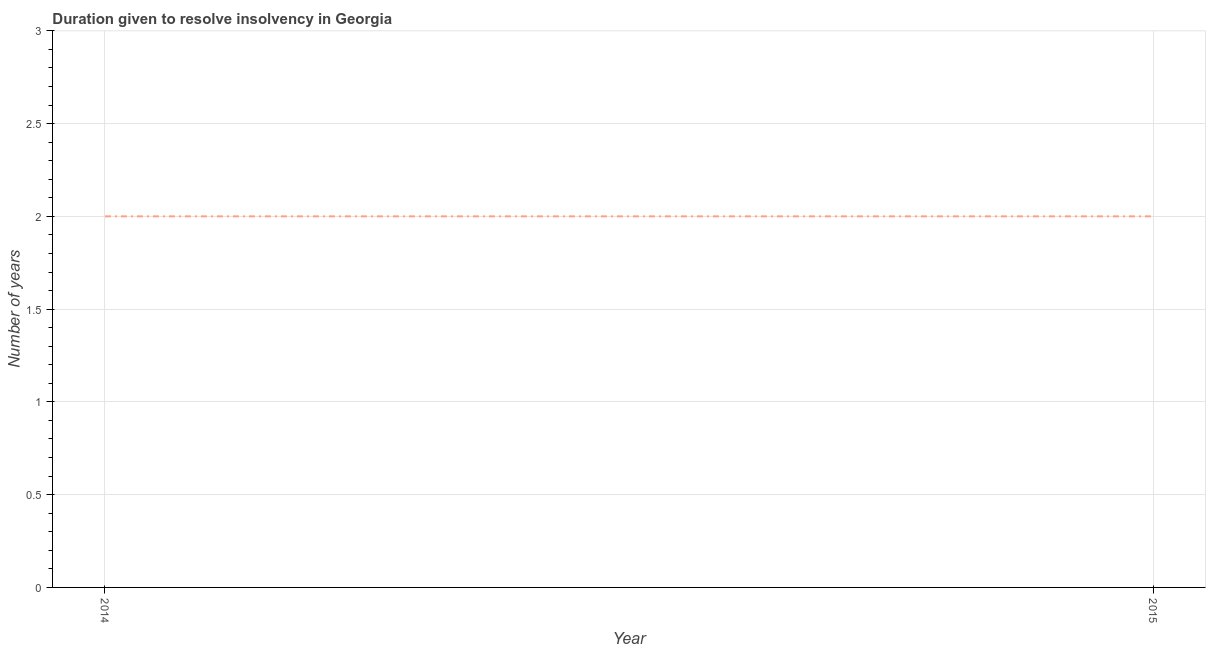What is the number of years to resolve insolvency in 2015?
Provide a short and direct response. 2. Across all years, what is the maximum number of years to resolve insolvency?
Your answer should be very brief. 2. Across all years, what is the minimum number of years to resolve insolvency?
Give a very brief answer. 2. In which year was the number of years to resolve insolvency maximum?
Give a very brief answer. 2014. What is the sum of the number of years to resolve insolvency?
Offer a very short reply. 4. What is the median number of years to resolve insolvency?
Your answer should be compact. 2. Do a majority of the years between 2015 and 2014 (inclusive) have number of years to resolve insolvency greater than 2.1 ?
Your answer should be very brief. No. What is the ratio of the number of years to resolve insolvency in 2014 to that in 2015?
Provide a short and direct response. 1. Is the number of years to resolve insolvency in 2014 less than that in 2015?
Provide a succinct answer. No. In how many years, is the number of years to resolve insolvency greater than the average number of years to resolve insolvency taken over all years?
Provide a short and direct response. 0. Does the number of years to resolve insolvency monotonically increase over the years?
Ensure brevity in your answer.  No. What is the difference between two consecutive major ticks on the Y-axis?
Offer a very short reply. 0.5. Are the values on the major ticks of Y-axis written in scientific E-notation?
Provide a succinct answer. No. Does the graph contain any zero values?
Ensure brevity in your answer.  No. Does the graph contain grids?
Provide a succinct answer. Yes. What is the title of the graph?
Make the answer very short. Duration given to resolve insolvency in Georgia. What is the label or title of the X-axis?
Make the answer very short. Year. What is the label or title of the Y-axis?
Provide a succinct answer. Number of years. What is the Number of years of 2014?
Ensure brevity in your answer.  2. What is the difference between the Number of years in 2014 and 2015?
Offer a terse response. 0. What is the ratio of the Number of years in 2014 to that in 2015?
Give a very brief answer. 1. 